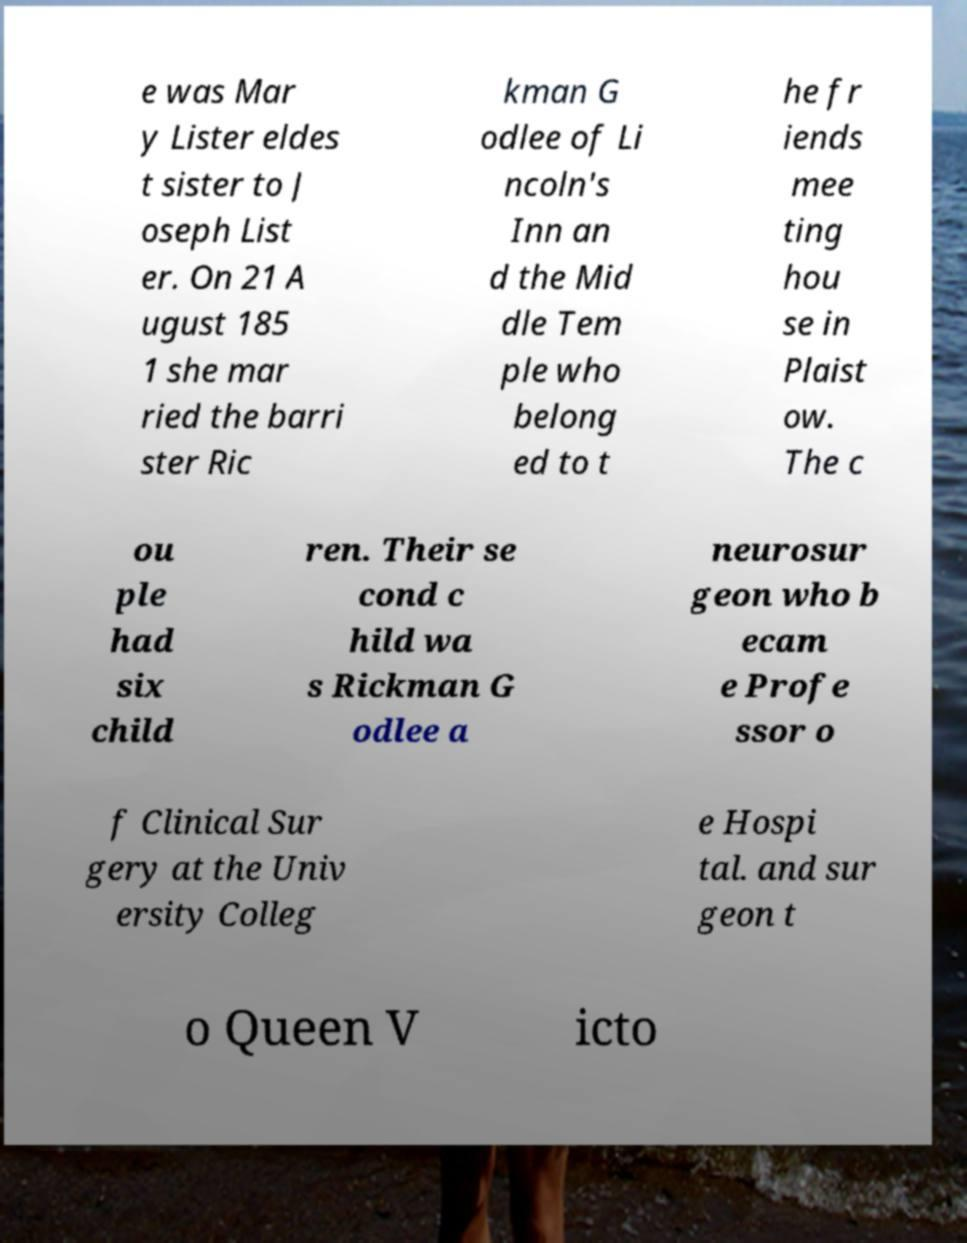What messages or text are displayed in this image? I need them in a readable, typed format. e was Mar y Lister eldes t sister to J oseph List er. On 21 A ugust 185 1 she mar ried the barri ster Ric kman G odlee of Li ncoln's Inn an d the Mid dle Tem ple who belong ed to t he fr iends mee ting hou se in Plaist ow. The c ou ple had six child ren. Their se cond c hild wa s Rickman G odlee a neurosur geon who b ecam e Profe ssor o f Clinical Sur gery at the Univ ersity Colleg e Hospi tal. and sur geon t o Queen V icto 